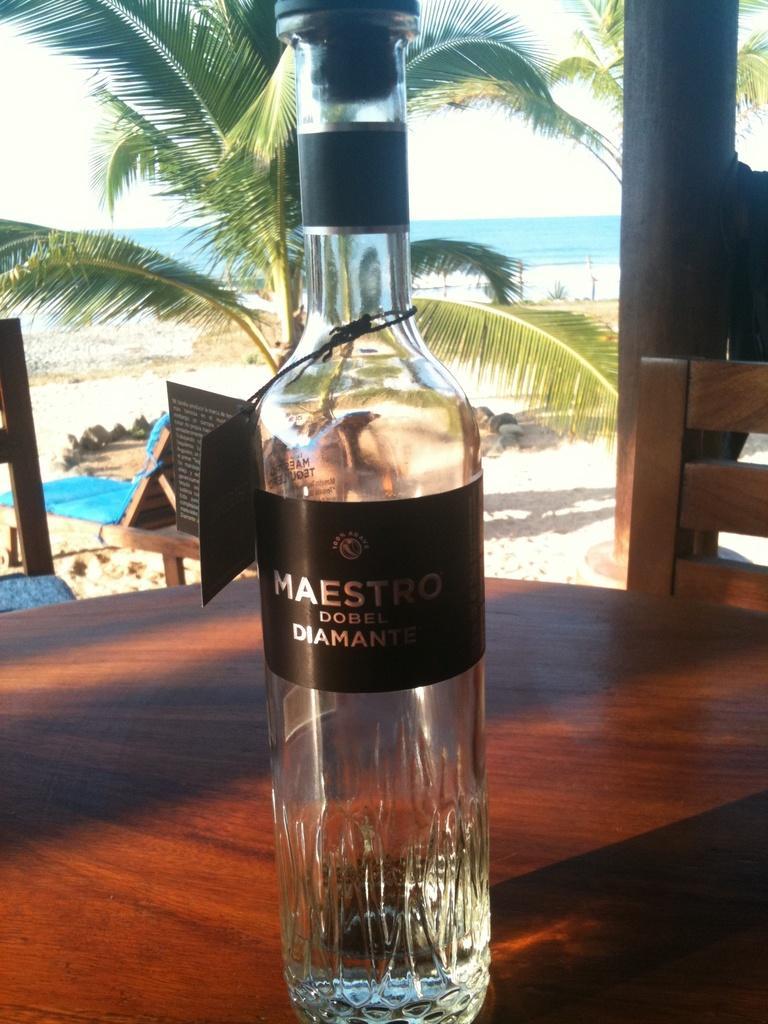Could you give a brief overview of what you see in this image? The glass bottle is placed on the table and there is a tree and beach in the background. 